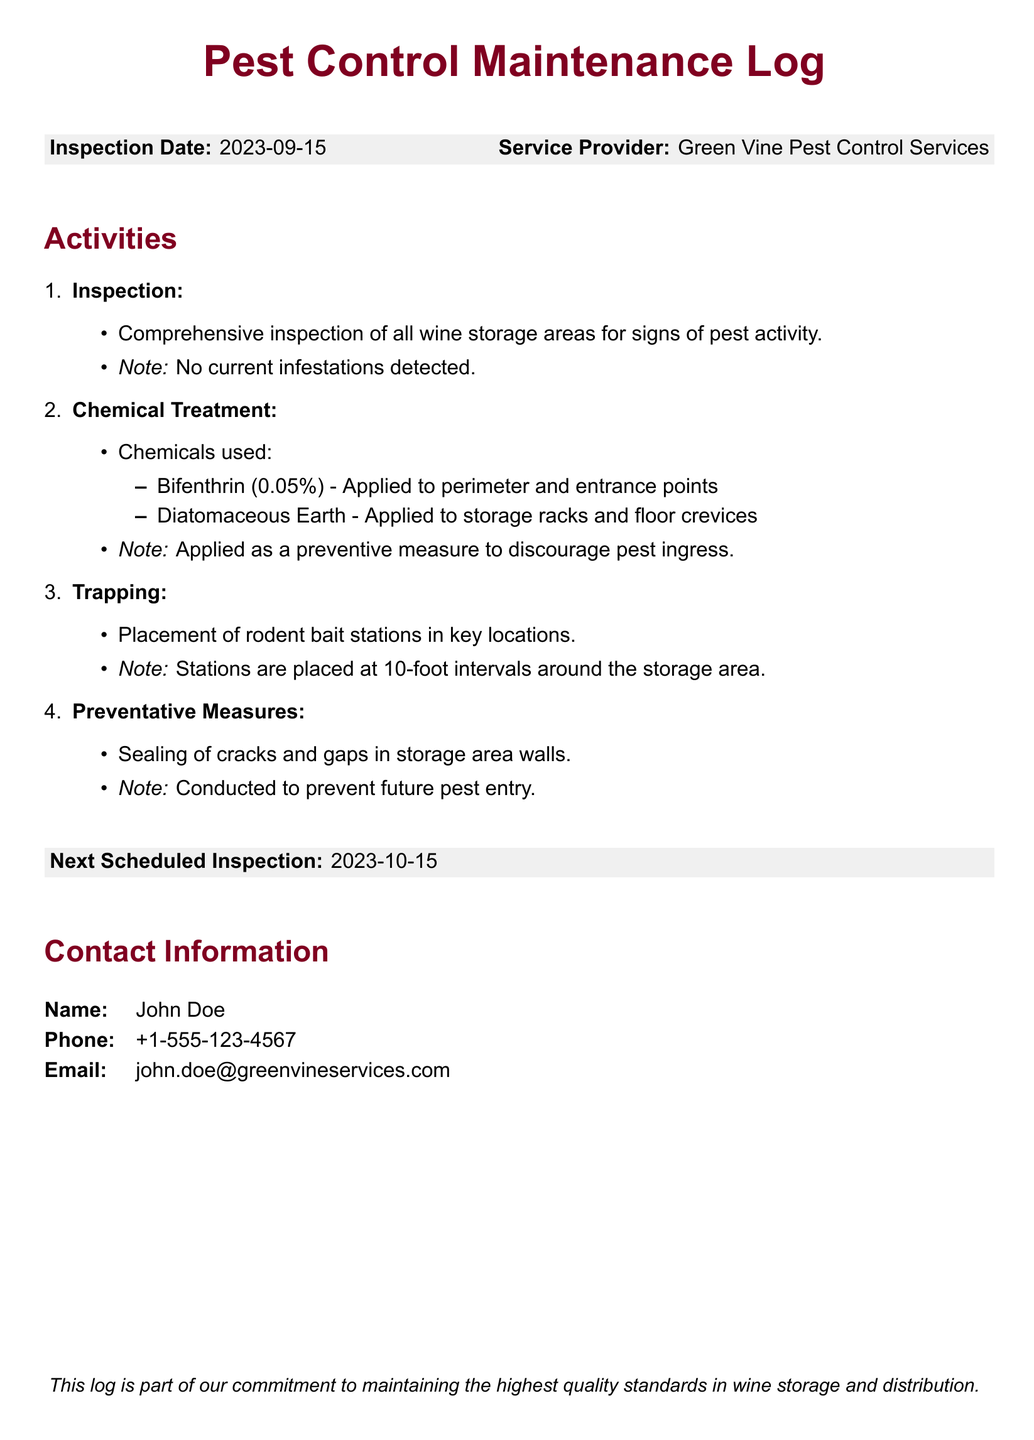What was the inspection date? The inspection date is mentioned clearly at the beginning of the log.
Answer: 2023-09-15 Who is the service provider? The service provider is specified in the document under the inspection details.
Answer: Green Vine Pest Control Services What chemicals were used in the treatment? The log lists the chemicals used in the chemical treatment section.
Answer: Bifenthrin, Diatomaceous Earth What is the percentage of Bifenthrin used? The specific concentration of Bifenthrin applied is noted in the chemical treatment section.
Answer: 0.05% When is the next scheduled inspection? The next scheduled inspection date is provided towards the end of the log.
Answer: 2023-10-15 What was the purpose of sealing cracks and gaps? The purpose of sealing is clearly stated under preventative measures for pest control.
Answer: Prevent future pest entry How often are rodent bait stations placed? The log details the arrangement of bait stations in the pest control measures.
Answer: 10-foot intervals Who should be contacted for more information? The contact information section lists the person to reach out to for questions.
Answer: John Doe 